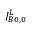<formula> <loc_0><loc_0><loc_500><loc_500>I _ { B 0 , 0 } ^ { L }</formula> 